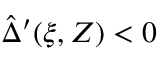Convert formula to latex. <formula><loc_0><loc_0><loc_500><loc_500>\hat { \Delta } ^ { \prime } ( \xi , Z ) < 0</formula> 